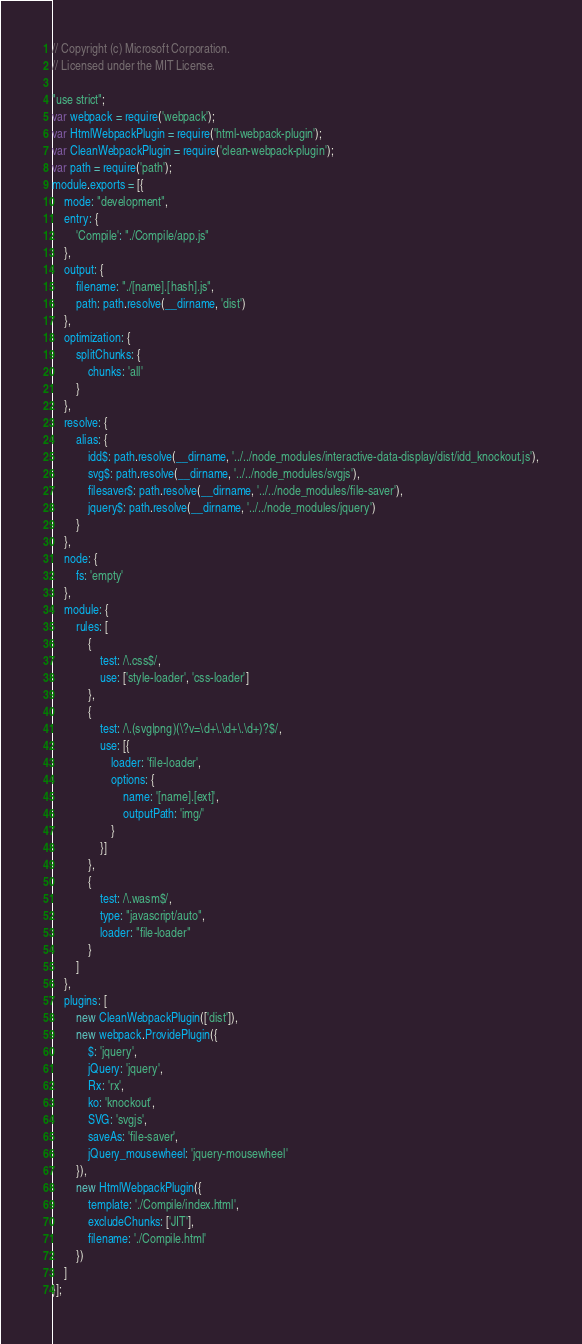Convert code to text. <code><loc_0><loc_0><loc_500><loc_500><_JavaScript_>// Copyright (c) Microsoft Corporation.
// Licensed under the MIT License.

"use strict";
var webpack = require('webpack');
var HtmlWebpackPlugin = require('html-webpack-plugin');
var CleanWebpackPlugin = require('clean-webpack-plugin');
var path = require('path');
module.exports = [{
    mode: "development",
    entry: {
        'Compile': "./Compile/app.js"
    },
    output: {
        filename: "./[name].[hash].js",
        path: path.resolve(__dirname, 'dist')
    },
    optimization: {
        splitChunks: {
            chunks: 'all'
        }
    },
    resolve: {
        alias: {
            idd$: path.resolve(__dirname, '../../node_modules/interactive-data-display/dist/idd_knockout.js'),
            svg$: path.resolve(__dirname, '../../node_modules/svgjs'),
            filesaver$: path.resolve(__dirname, '../../node_modules/file-saver'),
            jquery$: path.resolve(__dirname, '../../node_modules/jquery')
        }
    },
    node: {
        fs: 'empty'
    },
    module: {
        rules: [
            {
                test: /\.css$/,
                use: ['style-loader', 'css-loader']
            },
            {
                test: /\.(svg|png)(\?v=\d+\.\d+\.\d+)?$/,
                use: [{
                    loader: 'file-loader',
                    options: {
                        name: '[name].[ext]',
                        outputPath: 'img/'
                    }
                }]
            },
            {
                test: /\.wasm$/,
                type: "javascript/auto",
                loader: "file-loader"
            }
        ]
    },
    plugins: [
        new CleanWebpackPlugin(['dist']),
        new webpack.ProvidePlugin({
            $: 'jquery',
            jQuery: 'jquery',
            Rx: 'rx',
            ko: 'knockout',
            SVG: 'svgjs',
            saveAs: 'file-saver',
            jQuery_mousewheel: 'jquery-mousewheel'
        }),
        new HtmlWebpackPlugin({
            template: './Compile/index.html',
            excludeChunks: ['JIT'],
            filename: './Compile.html'
        })
    ]
}];</code> 